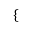Convert formula to latex. <formula><loc_0><loc_0><loc_500><loc_500>\left \{ \begin{array} { r l } \end{array}</formula> 